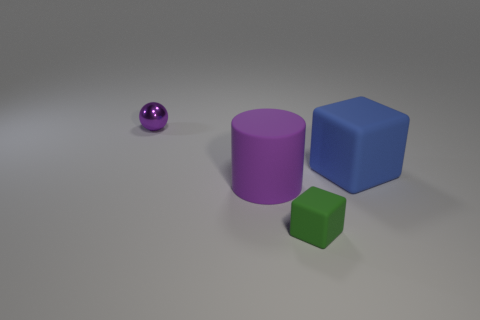Subtract all blue cubes. How many cubes are left? 1 Add 4 tiny green cylinders. How many objects exist? 8 Subtract all cylinders. How many objects are left? 3 Subtract all cyan cubes. Subtract all yellow spheres. How many cubes are left? 2 Subtract all green cylinders. How many green blocks are left? 1 Subtract all large cubes. Subtract all cyan metallic things. How many objects are left? 3 Add 1 tiny spheres. How many tiny spheres are left? 2 Add 4 tiny brown shiny cubes. How many tiny brown shiny cubes exist? 4 Subtract 0 green cylinders. How many objects are left? 4 Subtract 1 balls. How many balls are left? 0 